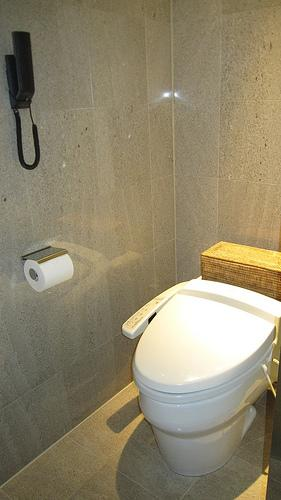Describe the main components of the bathroom in the image. The bathroom showcases a toilets, white toilet paper on a gold holder, a black phone mounted on the wall, and a brown wicker basket. Narrate what you see in the image in simple terms. I see a bathroom with a toilet, toilet paper, a phone on the wall, and a basket on top of the toilet. Provide a concise summary of the scene in the photograph. A bathroom with a white toilet, beige tiles on walls/floor, and various accessories including a phone, toilet paper, and wicker basket. Explain where the most important objects are located in the image. The white toilet is at the center, black phone on the upper-left wall, toilet paper on the left, and wicker basket at the back. Mention the colors and key items portrayed in the picture. White toilet, gold toilet paper holder, beige tiles, black phone, and brown wicker basket are present in the bathroom scene. Provide a description of the bathroom's appearance and items it contains. The bathroom has beige tiled walls and floors, featuring a white toilet, black wall-mounted phone, toilet paper, and a wicker basket. Identify the primary object in the image and provide a brief description. A large white toilet with a closed lid is the focal point, accompanied by a roll of toilet paper and a brown wicker basket. List the primary items in the picture and their functions. White toilet for use, toilet paper for cleaning, gold holder for holding paper, black phone for communication, and wicker basket for storage. Mention the key elements in the picture and their placements. White toilet at center, toilet paper on the left with a holder, black phone on upper-left wall, and wicker basket at the back. Describe the setting and environment of the image. The image features a bathroom with beige tiled floors and walls, a white toilet in the center, and various objects placed around it. 